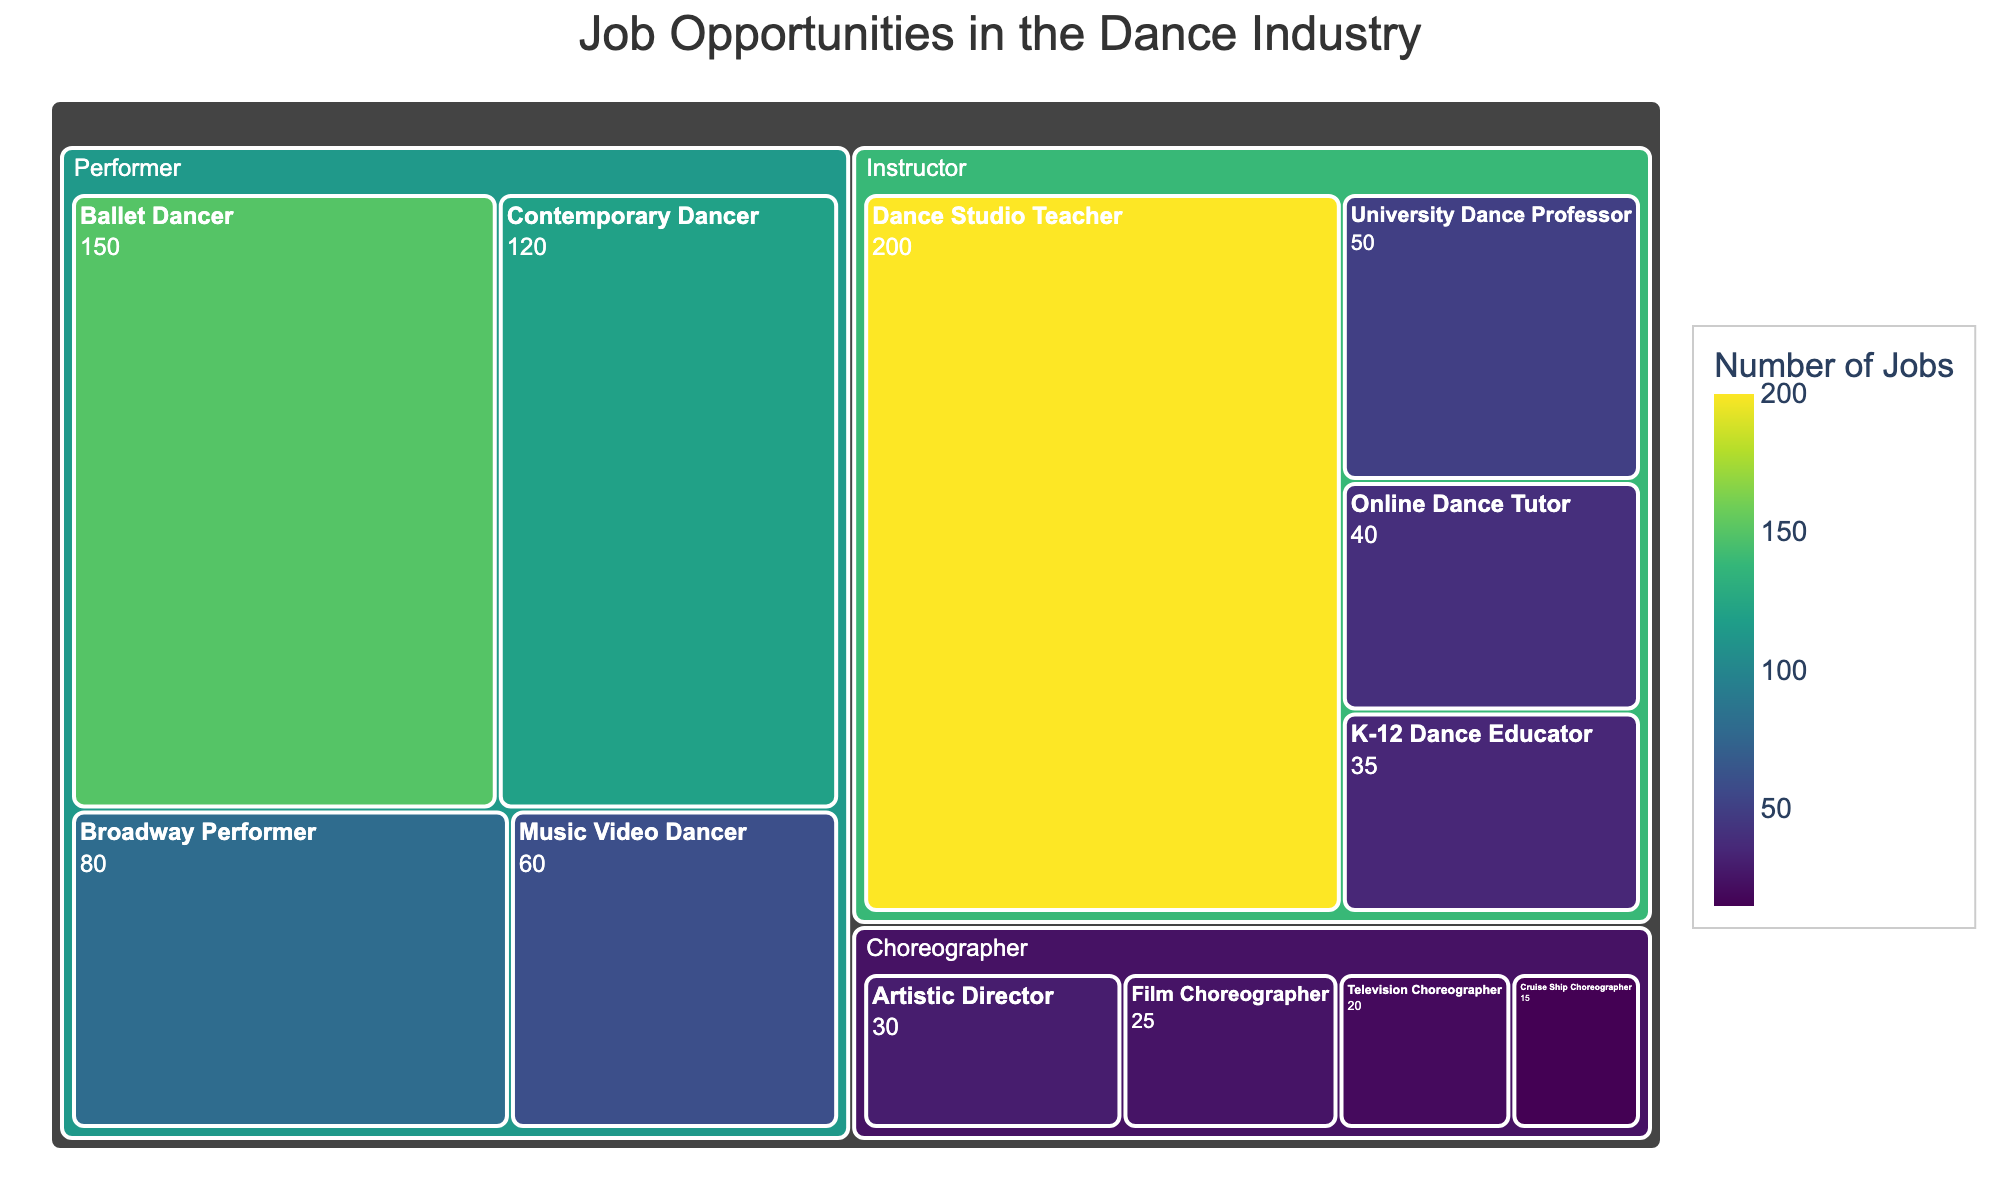What are the main categories in the dance industry Treemap? The treemap is divided into main categories, which are 'Performer', 'Choreographer', and 'Instructor'. These categories are the top level of the tree and help organize the structure of job types in the dance industry.
Answer: Performer, Choreographer, Instructor Which role has the highest number of jobs in the entire dance industry treemap? By looking at the relative sizes of the blocks and their labels, the 'Dance Studio Teacher' under the 'Instructor' category has the largest block, indicating it has the highest number of jobs.
Answer: Dance Studio Teacher How many total performer jobs are available according to the figure? The roles under the 'Performer' category are 'Ballet Dancer', 'Contemporary Dancer', 'Broadway Performer', and 'Music Video Dancer'. Summing up their jobs: 150 + 120 + 80 + 60 = 410.
Answer: 410 Compare the number of jobs for 'Artistic Director' and 'Film Choreographer'. Which one has more, and by how much? 'Artistic Director' has 30 jobs while 'Film Choreographer' has 25. The difference can be calculated as 30 - 25. Hence, 'Artistic Director' has 5 more jobs than 'Film Choreographer'.
Answer: Artistic Director, by 5 What's the average number of jobs for the roles under the 'Instructor' category? The roles under 'Instructor' have job numbers 200, 50, 40, and 35. To find the average: (200 + 50 + 40 + 35) / 4 = 325 / 4 = 81.25.
Answer: 81.25 Which category (Performer, Choreographer, Instructor) has the smallest total number of jobs, and what's that total? Summing jobs for each category:
Performer: 150 + 120 + 80 + 60 = 410
Choreographer: 30 + 25 + 20 + 15 = 90
Instructor: 200 + 50 + 40 + 35 = 325
The Choreographer category has the smallest total, which is 90.
Answer: Choreographer, 90 How many more jobs are available for 'Dance Studio Teacher' compared to 'University Dance Professor'? 'Dance Studio Teacher' has 200 jobs and 'University Dance Professor' has 50 jobs. The difference is 200 - 50 = 150.
Answer: 150 more Which role has the least number of jobs within the Performer category? Within the Performer category, the roles and their job numbers are: Ballet Dancer (150), Contemporary Dancer (120), Broadway Performer (80), and Music Video Dancer (60). The 'Music Video Dancer' has the least number of jobs.
Answer: Music Video Dancer What is the combined total number of jobs for 'Online Dance Tutor' and 'K-12 Dance Educator' roles? The 'Online Dance Tutor' has 40 jobs, and the 'K-12 Dance Educator' has 35 jobs. Their combined total is 40 + 35 = 75.
Answer: 75 